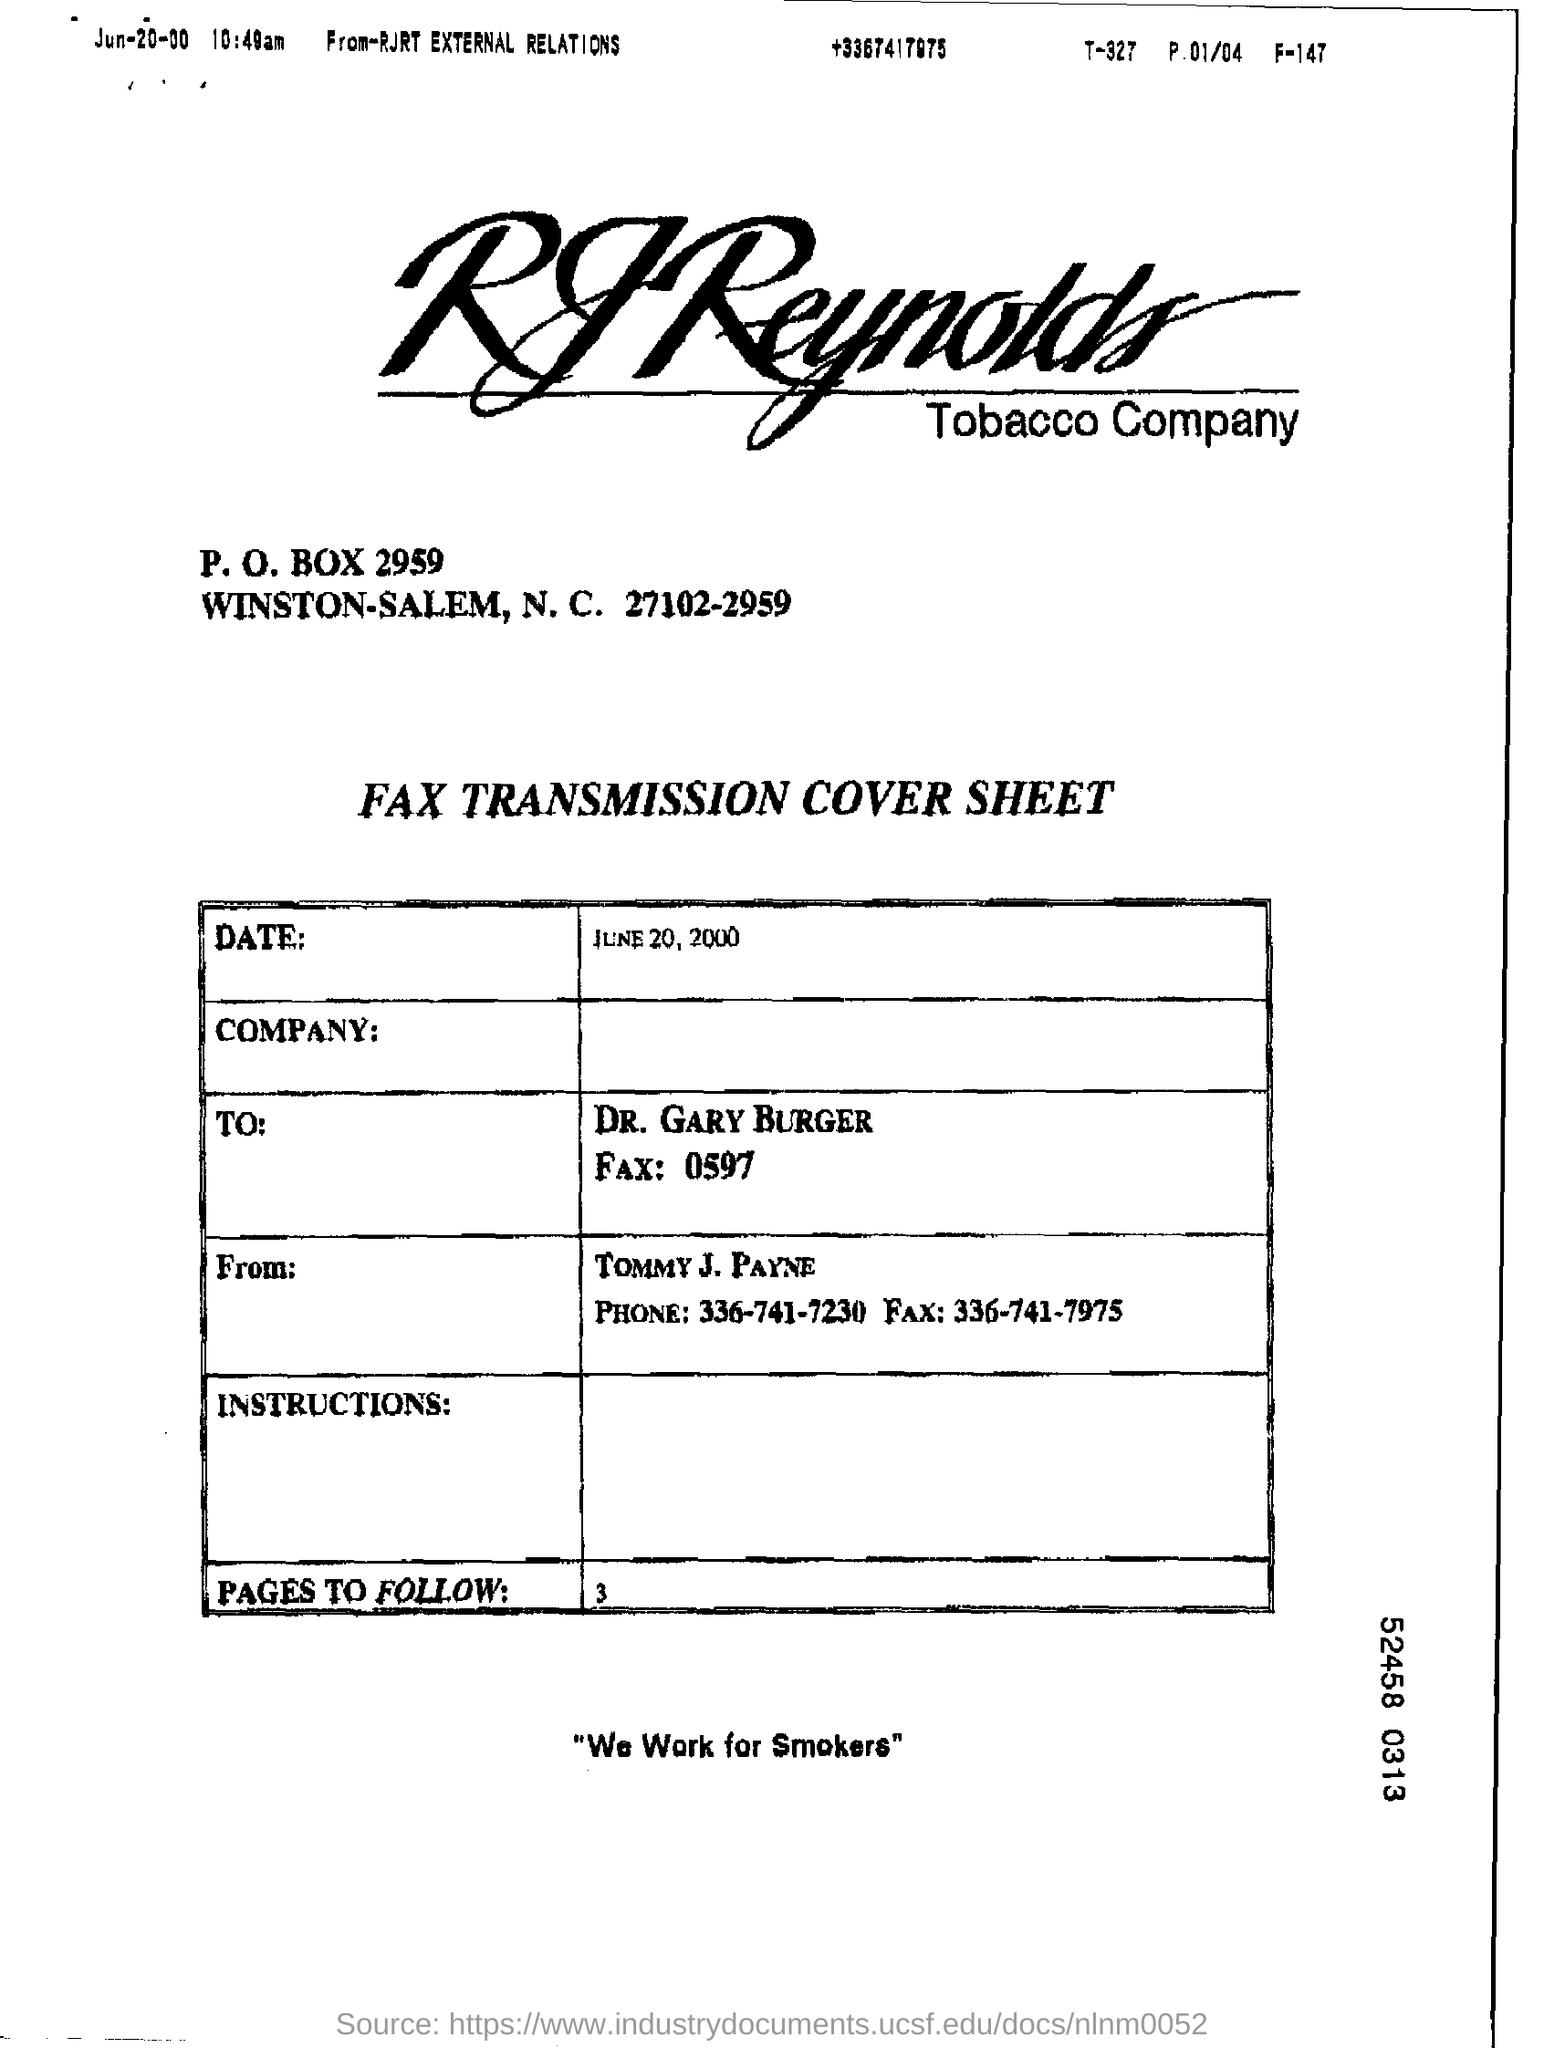List a handful of essential elements in this visual. The phrase 'We Work for Smokers' is written at the bottom of the page. The RJ Reynolds Tobacco Company is the company whose name appears at the top of the page. The sender is Tommy J. Payne. 